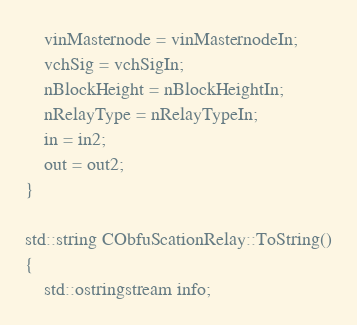<code> <loc_0><loc_0><loc_500><loc_500><_C++_>    vinMasternode = vinMasternodeIn;
    vchSig = vchSigIn;
    nBlockHeight = nBlockHeightIn;
    nRelayType = nRelayTypeIn;
    in = in2;
    out = out2;
}

std::string CObfuScationRelay::ToString()
{
    std::ostringstream info;
</code> 